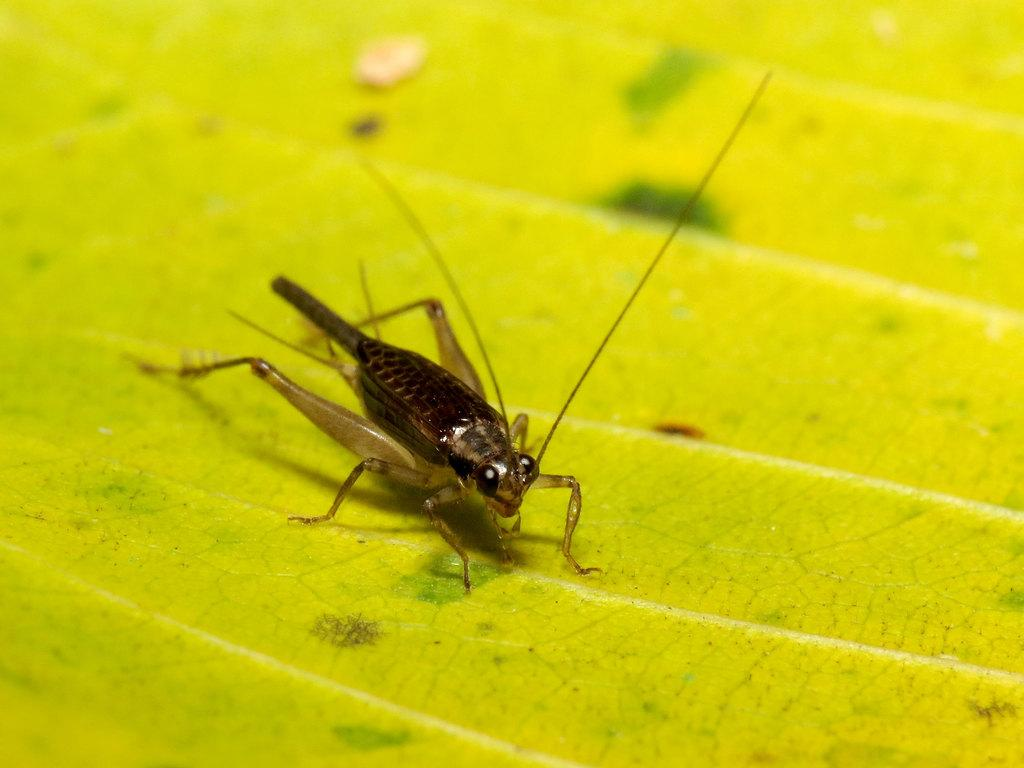What is the main subject of the image? The main subject of the image is a mosquito. Where is the mosquito located in the image? The mosquito is on a leaf in the image. What type of jelly can be seen on the mosquito's skin in the image? There is no jelly or skin present in the image, as it features a mosquito on a leaf. What fictional character is depicted in the image? There is no fictional character depicted in the image; it features a mosquito on a leaf. 